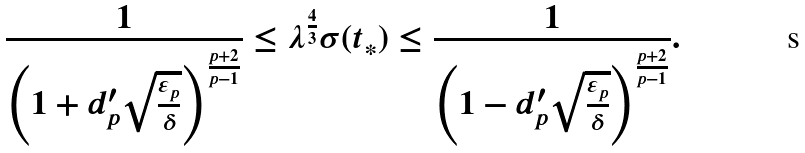Convert formula to latex. <formula><loc_0><loc_0><loc_500><loc_500>\frac { 1 } { \left ( 1 + d ^ { \prime } _ { p } \sqrt { \frac { \varepsilon _ { p } } { \delta } } \right ) ^ { \frac { p + 2 } { p - 1 } } } \leq \lambda ^ { \frac { 4 } { 3 } } \sigma ( t _ { \ast } ) \leq \frac { 1 } { \left ( 1 - d ^ { \prime } _ { p } \sqrt { \frac { \varepsilon _ { p } } { \delta } } \right ) ^ { \frac { p + 2 } { p - 1 } } } .</formula> 